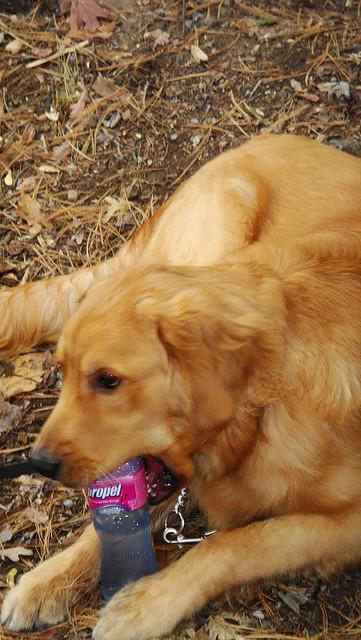Is this dog eating dog food?
Answer briefly. No. What kind of dog is this?
Write a very short answer. Golden retriever. Is this scene happening inside or outside?
Quick response, please. Outside. Is the dog drinking a bottle of water?
Keep it brief. No. 